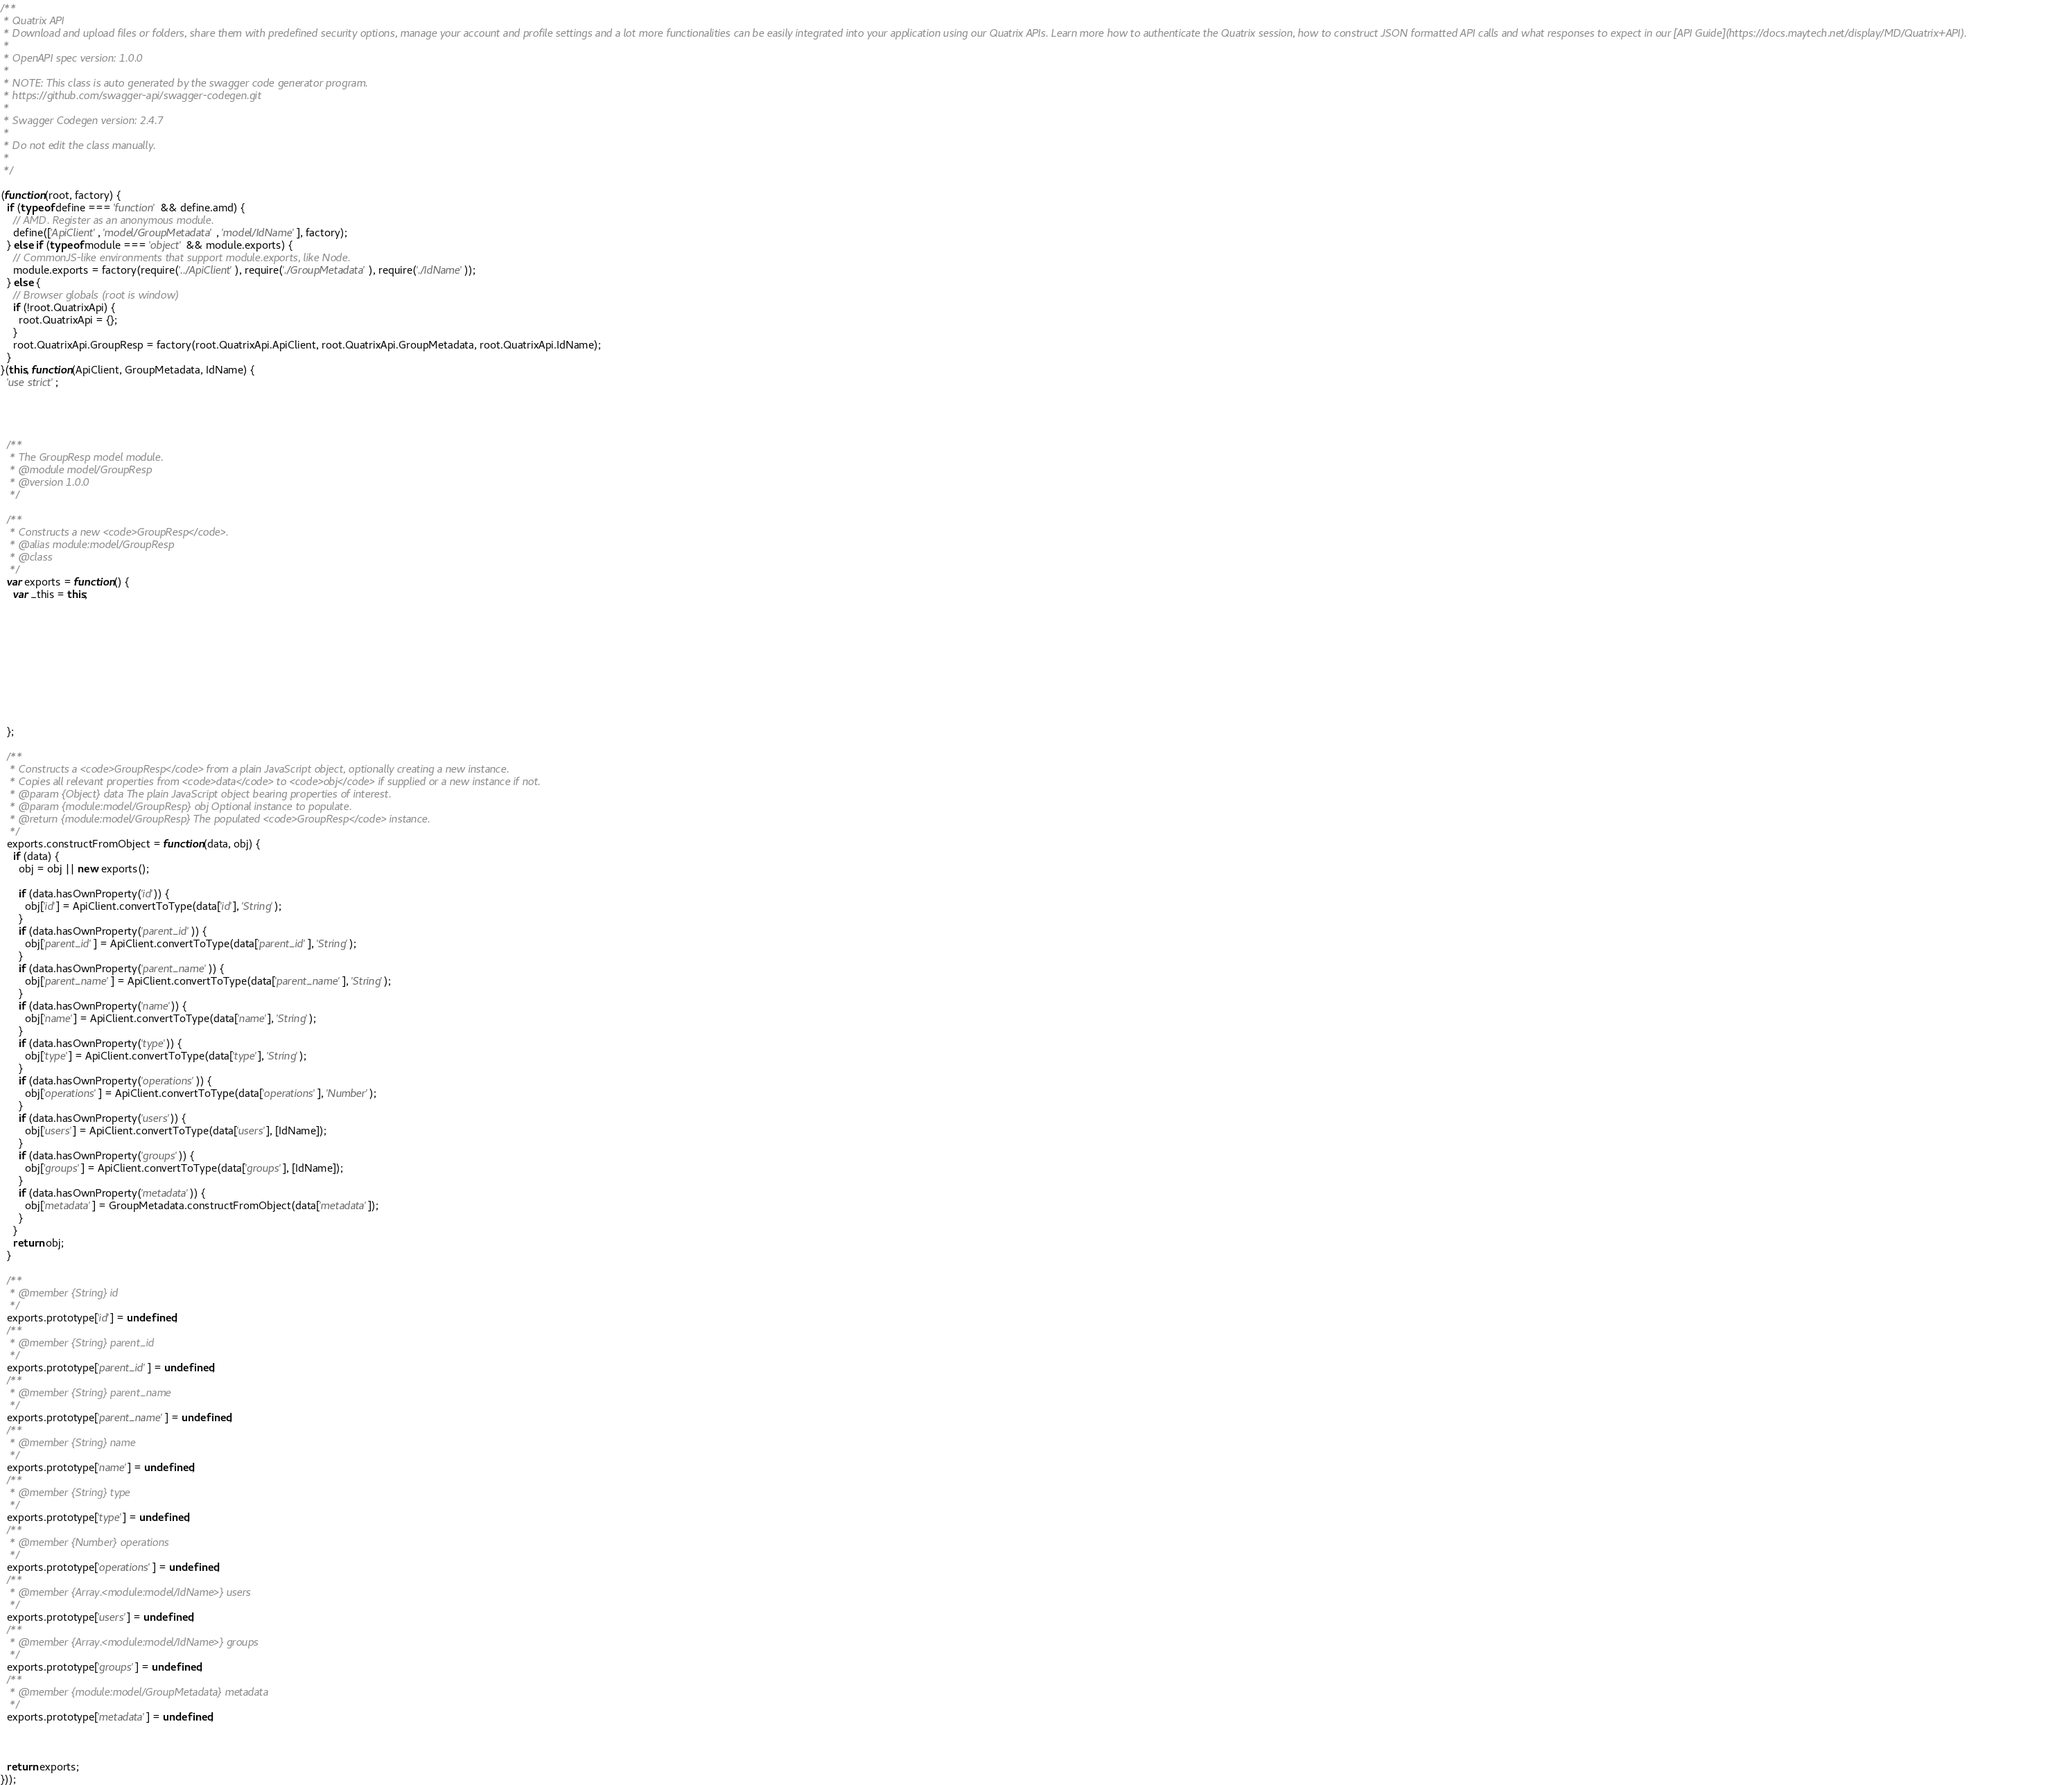Convert code to text. <code><loc_0><loc_0><loc_500><loc_500><_JavaScript_>/**
 * Quatrix API
 * Download and upload files or folders, share them with predefined security options, manage your account and profile settings and a lot more functionalities can be easily integrated into your application using our Quatrix APIs. Learn more how to authenticate the Quatrix session, how to construct JSON formatted API calls and what responses to expect in our [API Guide](https://docs.maytech.net/display/MD/Quatrix+API).
 *
 * OpenAPI spec version: 1.0.0
 *
 * NOTE: This class is auto generated by the swagger code generator program.
 * https://github.com/swagger-api/swagger-codegen.git
 *
 * Swagger Codegen version: 2.4.7
 *
 * Do not edit the class manually.
 *
 */

(function(root, factory) {
  if (typeof define === 'function' && define.amd) {
    // AMD. Register as an anonymous module.
    define(['ApiClient', 'model/GroupMetadata', 'model/IdName'], factory);
  } else if (typeof module === 'object' && module.exports) {
    // CommonJS-like environments that support module.exports, like Node.
    module.exports = factory(require('../ApiClient'), require('./GroupMetadata'), require('./IdName'));
  } else {
    // Browser globals (root is window)
    if (!root.QuatrixApi) {
      root.QuatrixApi = {};
    }
    root.QuatrixApi.GroupResp = factory(root.QuatrixApi.ApiClient, root.QuatrixApi.GroupMetadata, root.QuatrixApi.IdName);
  }
}(this, function(ApiClient, GroupMetadata, IdName) {
  'use strict';




  /**
   * The GroupResp model module.
   * @module model/GroupResp
   * @version 1.0.0
   */

  /**
   * Constructs a new <code>GroupResp</code>.
   * @alias module:model/GroupResp
   * @class
   */
  var exports = function() {
    var _this = this;










  };

  /**
   * Constructs a <code>GroupResp</code> from a plain JavaScript object, optionally creating a new instance.
   * Copies all relevant properties from <code>data</code> to <code>obj</code> if supplied or a new instance if not.
   * @param {Object} data The plain JavaScript object bearing properties of interest.
   * @param {module:model/GroupResp} obj Optional instance to populate.
   * @return {module:model/GroupResp} The populated <code>GroupResp</code> instance.
   */
  exports.constructFromObject = function(data, obj) {
    if (data) {
      obj = obj || new exports();

      if (data.hasOwnProperty('id')) {
        obj['id'] = ApiClient.convertToType(data['id'], 'String');
      }
      if (data.hasOwnProperty('parent_id')) {
        obj['parent_id'] = ApiClient.convertToType(data['parent_id'], 'String');
      }
      if (data.hasOwnProperty('parent_name')) {
        obj['parent_name'] = ApiClient.convertToType(data['parent_name'], 'String');
      }
      if (data.hasOwnProperty('name')) {
        obj['name'] = ApiClient.convertToType(data['name'], 'String');
      }
      if (data.hasOwnProperty('type')) {
        obj['type'] = ApiClient.convertToType(data['type'], 'String');
      }
      if (data.hasOwnProperty('operations')) {
        obj['operations'] = ApiClient.convertToType(data['operations'], 'Number');
      }
      if (data.hasOwnProperty('users')) {
        obj['users'] = ApiClient.convertToType(data['users'], [IdName]);
      }
      if (data.hasOwnProperty('groups')) {
        obj['groups'] = ApiClient.convertToType(data['groups'], [IdName]);
      }
      if (data.hasOwnProperty('metadata')) {
        obj['metadata'] = GroupMetadata.constructFromObject(data['metadata']);
      }
    }
    return obj;
  }

  /**
   * @member {String} id
   */
  exports.prototype['id'] = undefined;
  /**
   * @member {String} parent_id
   */
  exports.prototype['parent_id'] = undefined;
  /**
   * @member {String} parent_name
   */
  exports.prototype['parent_name'] = undefined;
  /**
   * @member {String} name
   */
  exports.prototype['name'] = undefined;
  /**
   * @member {String} type
   */
  exports.prototype['type'] = undefined;
  /**
   * @member {Number} operations
   */
  exports.prototype['operations'] = undefined;
  /**
   * @member {Array.<module:model/IdName>} users
   */
  exports.prototype['users'] = undefined;
  /**
   * @member {Array.<module:model/IdName>} groups
   */
  exports.prototype['groups'] = undefined;
  /**
   * @member {module:model/GroupMetadata} metadata
   */
  exports.prototype['metadata'] = undefined;



  return exports;
}));


</code> 